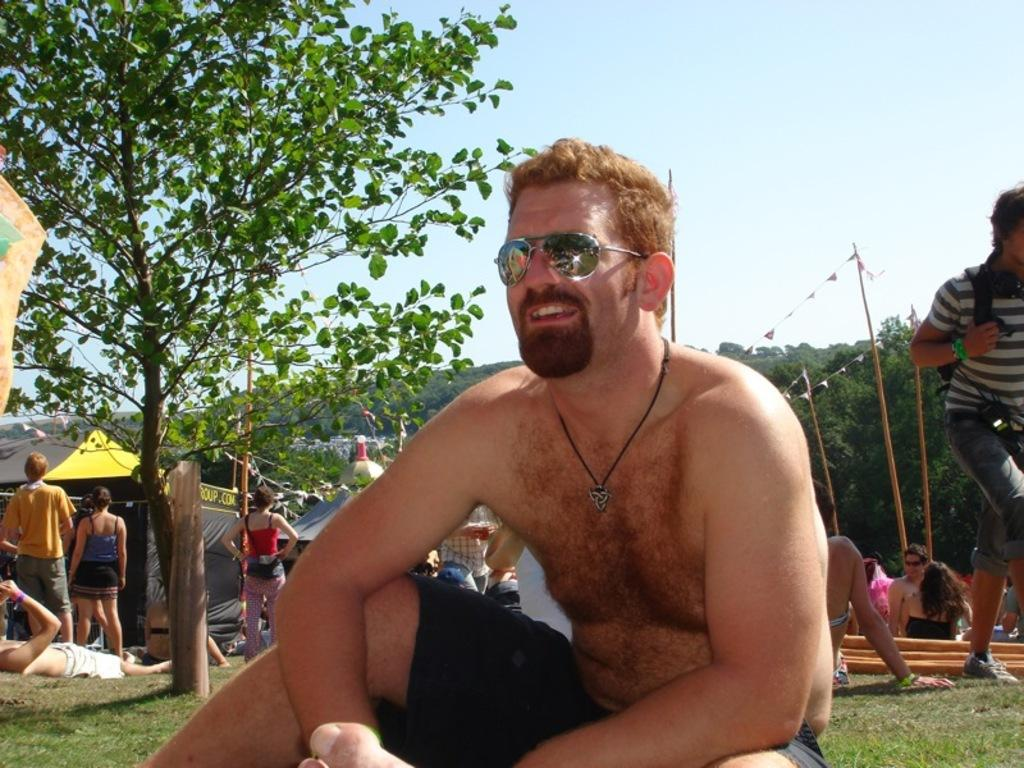What is the main subject of the image? There is a person in the image. Can you describe the surrounding environment? There are other people behind the person, and there are tents and poles in the image. What can be seen in the background of the image? There are trees and the sky visible in the background of the image. What type of receipt can be seen hanging from the pole in the image? There is no receipt present in the image; it features a person, other people, tents, poles, trees, and the sky. Can you tell me how many horns are visible on the person in the image? There are no horns visible on the person in the image. 